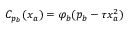Convert formula to latex. <formula><loc_0><loc_0><loc_500><loc_500>C _ { p _ { b } } ( x _ { a } ) = \varphi _ { b } ( p _ { b } - \tau x _ { a } ^ { 2 } )</formula> 